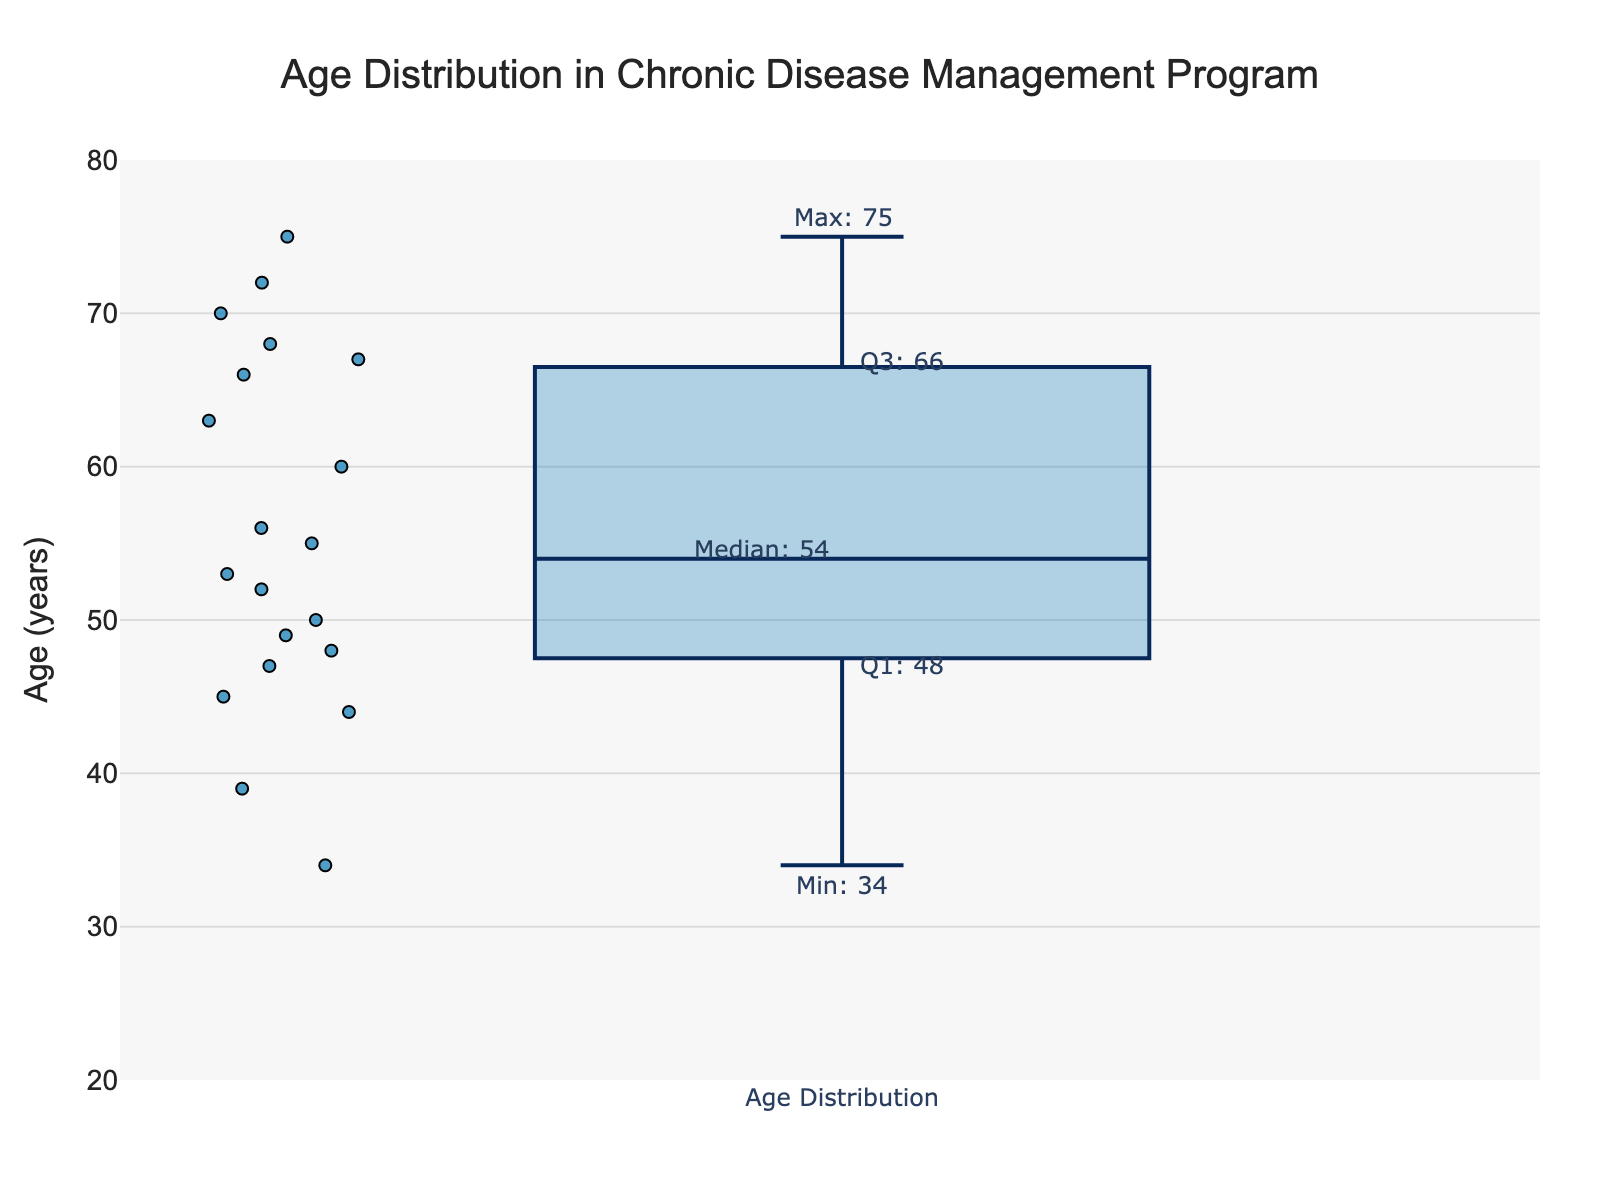What is the median age of patients in the chronic disease management program? The figure indicates the median as one of the statistical annotations, marked with a label. By reading this label, we can directly identify the median age.
Answer: 52 What is the maximum age of the patients in the chronic disease management program? The maximum age is indicated by the upper whisker of the box plot and is labeled with a statistical annotation as "Max." By reading this label, we can determine the maximum age.
Answer: 75 What is the interquartile range (IQR) of the ages of the patients? The IQR is calculated as the difference between the third quartile (Q3) and the first quartile (Q1). The values for Q3 and Q1 are labeled on the box plot as 60 and 47, respectively. Subtract Q1 from Q3 to find the IQR: 60 - 47.
Answer: 13 Which age is represented by the lower whisker in the plot? The lower whisker represents the minimum age or the smallest value within 1.5 times the IQR from Q1. This value is annotated on the plot as "Min."
Answer: 34 What is the range of ages covered by the whiskers in the box plot? The range of ages covered by the whiskers is the difference between the maximum and minimum values specified by the whiskers. These are annotated as Max (75) and Min (34), respectively. Calculate the range as 75 - 34.
Answer: 41 How does the median age compare to the first quartile age? The first quartile (Q1) is labeled as 47 and the median is labeled as 52 on the box plot. The median is the value separating the higher half from the lower half of the data. Compare these two values to find the difference: 52 - 47.
Answer: 5 What is the significance of the color and size of the markers in the box plot? The markers represent individual data points, their size and color enhance visibility and distinguish them from the box and whiskers. The blue color and varying sizes indicate these distribution points around the median, interquartile range, and whiskers.
Answer: Represents individual data points How do the ages of patients in the upper quartile compare to the ages in the lower quartile? The upper quartile (Q3) is labeled as 60 and represents the top 25% of ages, while the lower quartile (Q1) at 47 represents the bottom 25%. The difference gives the spread between these quartiles: 60 - 47.
Answer: 13 How many quartiles are represented in this box plot? A box plot typically represents four quartiles: the minimum, Q1 (first quartile), the median (second quartile), Q3 (third quartile), and the maximum. The plot visually splits the dataset into these quartiles.
Answer: 4 